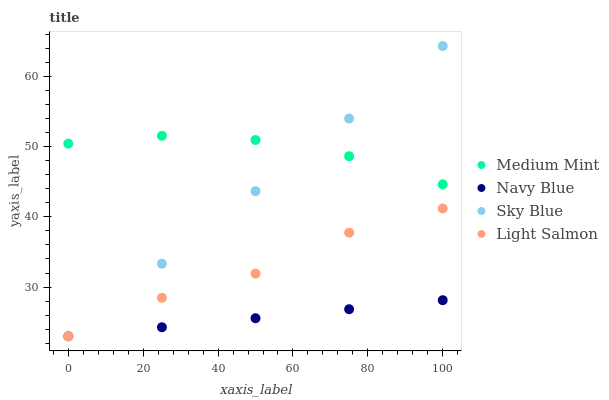Does Navy Blue have the minimum area under the curve?
Answer yes or no. Yes. Does Medium Mint have the maximum area under the curve?
Answer yes or no. Yes. Does Light Salmon have the minimum area under the curve?
Answer yes or no. No. Does Light Salmon have the maximum area under the curve?
Answer yes or no. No. Is Navy Blue the smoothest?
Answer yes or no. Yes. Is Light Salmon the roughest?
Answer yes or no. Yes. Is Light Salmon the smoothest?
Answer yes or no. No. Is Navy Blue the roughest?
Answer yes or no. No. Does Navy Blue have the lowest value?
Answer yes or no. Yes. Does Sky Blue have the highest value?
Answer yes or no. Yes. Does Light Salmon have the highest value?
Answer yes or no. No. Is Light Salmon less than Medium Mint?
Answer yes or no. Yes. Is Medium Mint greater than Navy Blue?
Answer yes or no. Yes. Does Sky Blue intersect Light Salmon?
Answer yes or no. Yes. Is Sky Blue less than Light Salmon?
Answer yes or no. No. Is Sky Blue greater than Light Salmon?
Answer yes or no. No. Does Light Salmon intersect Medium Mint?
Answer yes or no. No. 